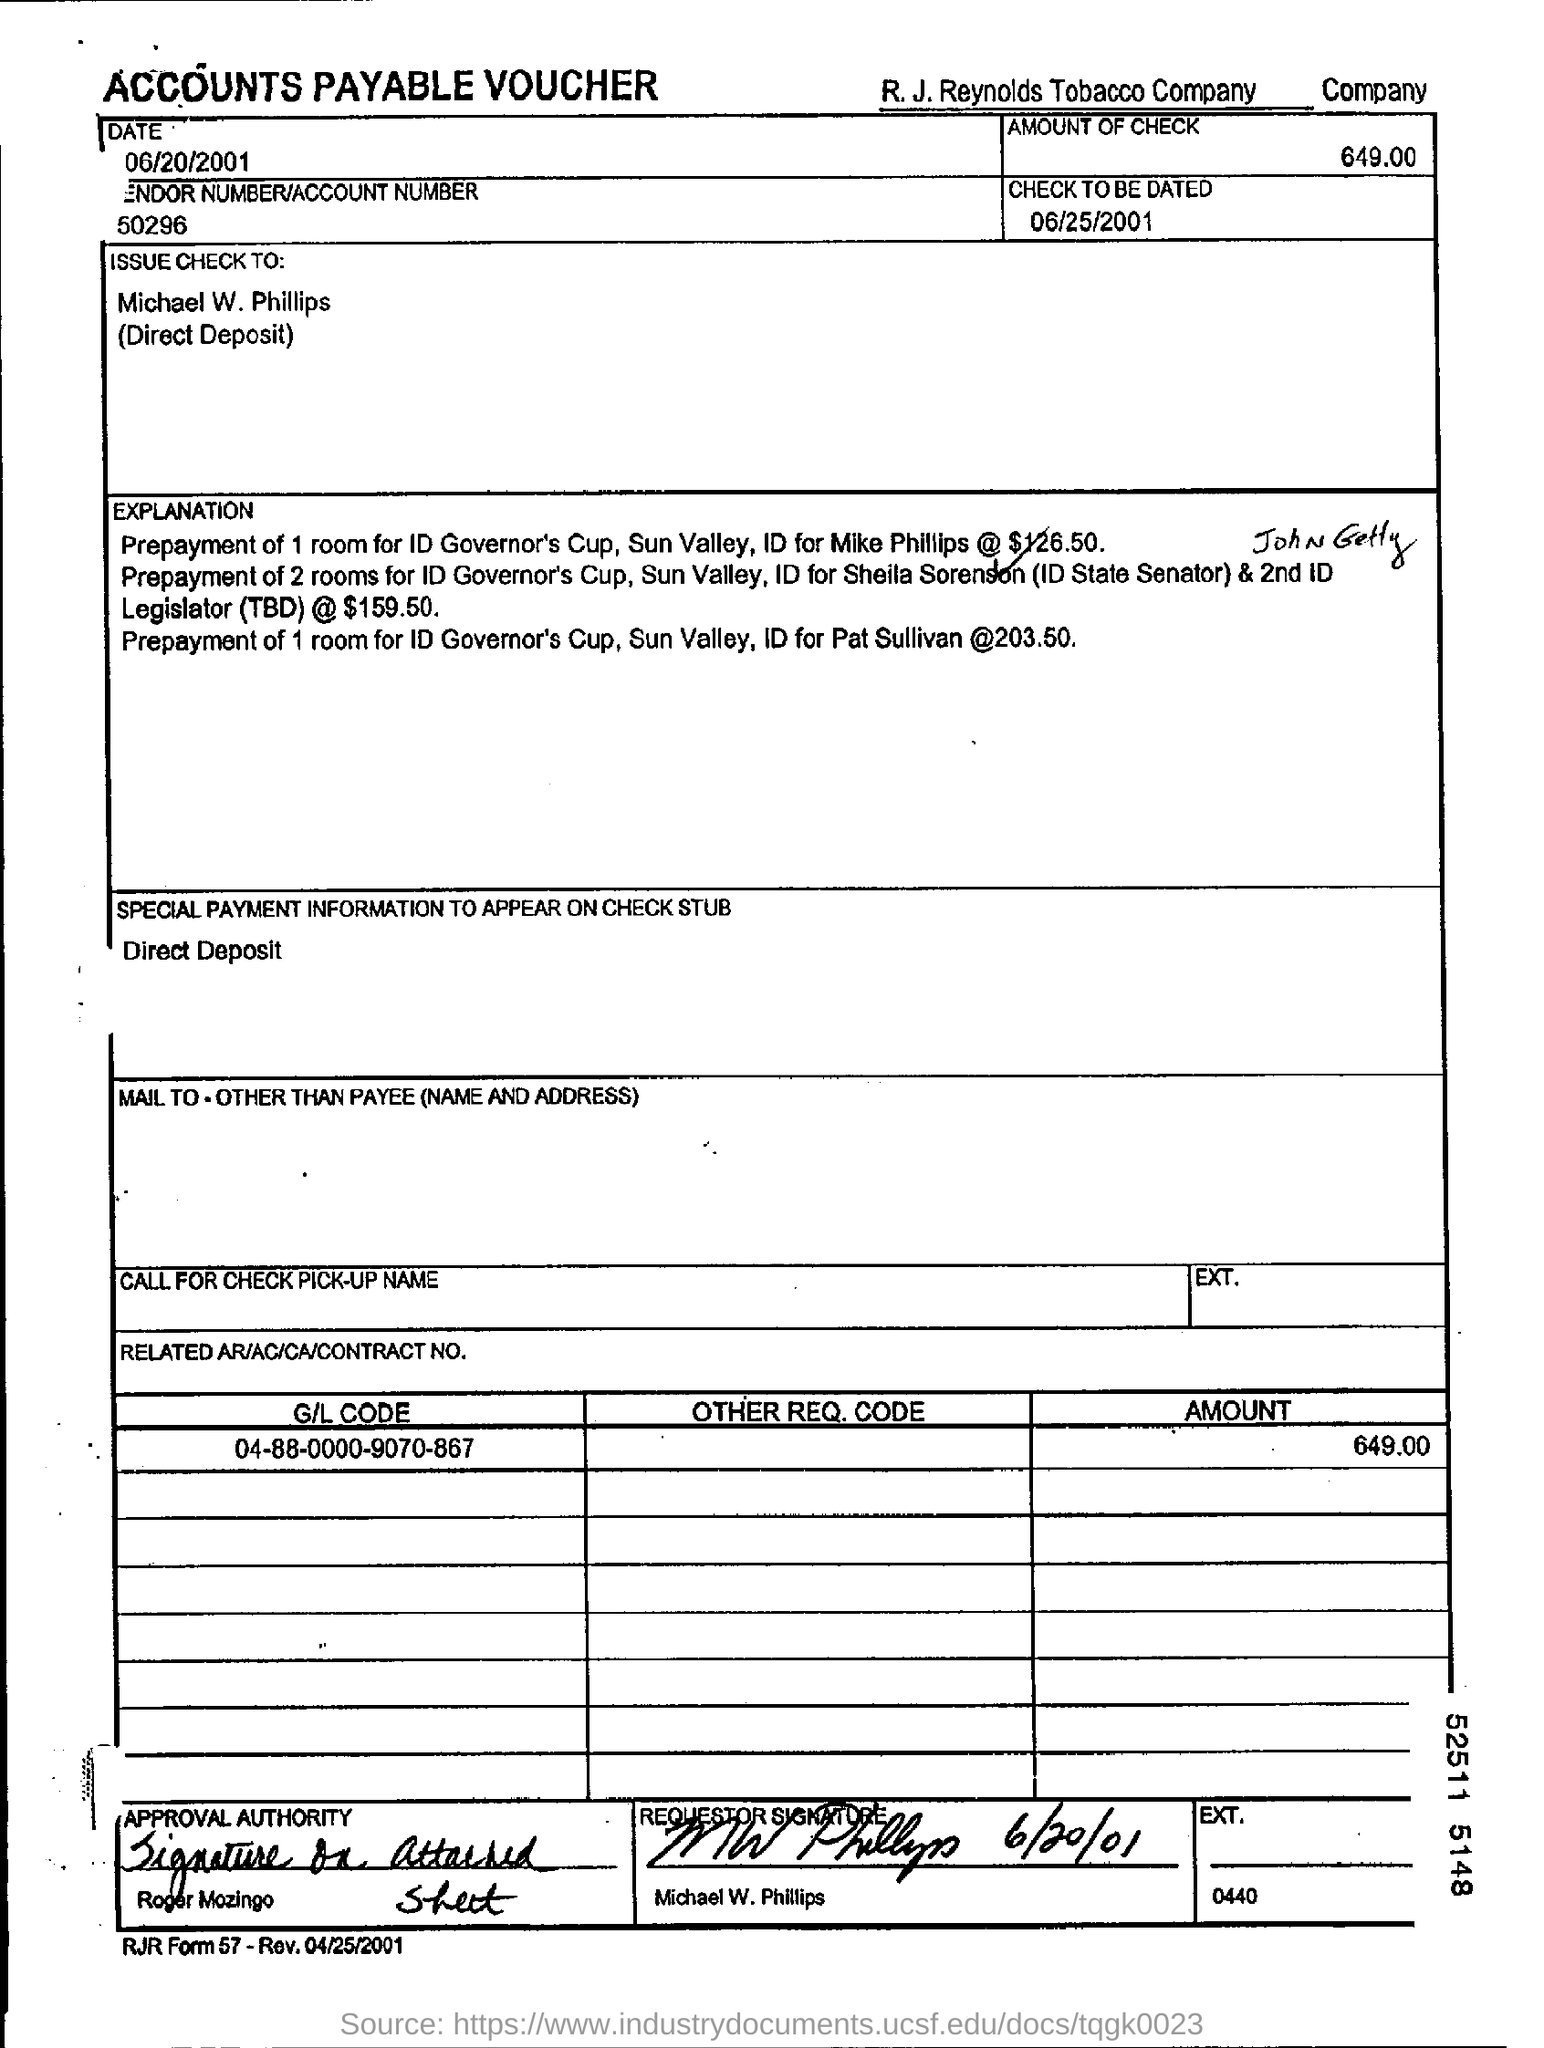Outline some significant characteristics in this image. The company at the top of the document is named R.J. Reynolds Tobacco Company. The date mentioned in this document is June 20, 2001. The check is issued to Michael W. Phillips. The amount of the check is 649.00. On June 25th, 2001, the phrase "CHECK TO BE DATED" was used. 